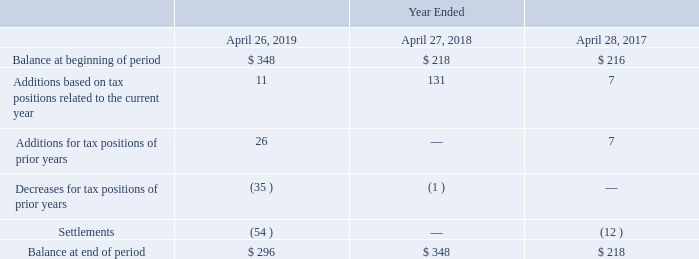A reconciliation of the beginning and ending amount of unrecognized tax benefits is as follows (in millions):
As of April 26, 2019, we had $296 million of gross unrecognized tax benefits, of which $252 million has been recorded in other long-term liabilities. Unrecognized tax benefits of $246 million, including penalties, interest and indirect benefits, would affect our provision for income taxes if recognized. As a result of U.S. tax reform, we recorded provisional gross unrecognized tax benefits of $114 million during fiscal 2018.
We recognized a benefit for adjustments to accrued interest and penalties related to unrecognized tax benefits in the income tax provision of approximately $4 million in fiscal 2019 and expense of $5 million in each of fiscal 2018 and 2017. Accrued interest and penalties of $18 million and $22 million were recorded in the consolidated balance sheets as of April 26, 2019 and April 27, 2018, respectively.
How much was the amount of gross unrecognized tax benefits in 2019? $296 million. Which years does the table provide information for the reconciliation of the beginning and ending amount of unrecognized tax benefits? 2019, 2018, 2017. What were the Additions based on tax positions related to the current year in 2019?
Answer scale should be: million. 11. What was the change in the Balance at beginning of period between 2017 and 2018?
Answer scale should be: million. 218-216
Answer: 2. What was the total change in Additions for tax positions of prior years between 2017 and 2019?
Answer scale should be: million. 26-7
Answer: 19. What was the percentage change in the Balance at end of period between 2018 and 2019?
Answer scale should be: percent. (296-348)/348
Answer: -14.94. 